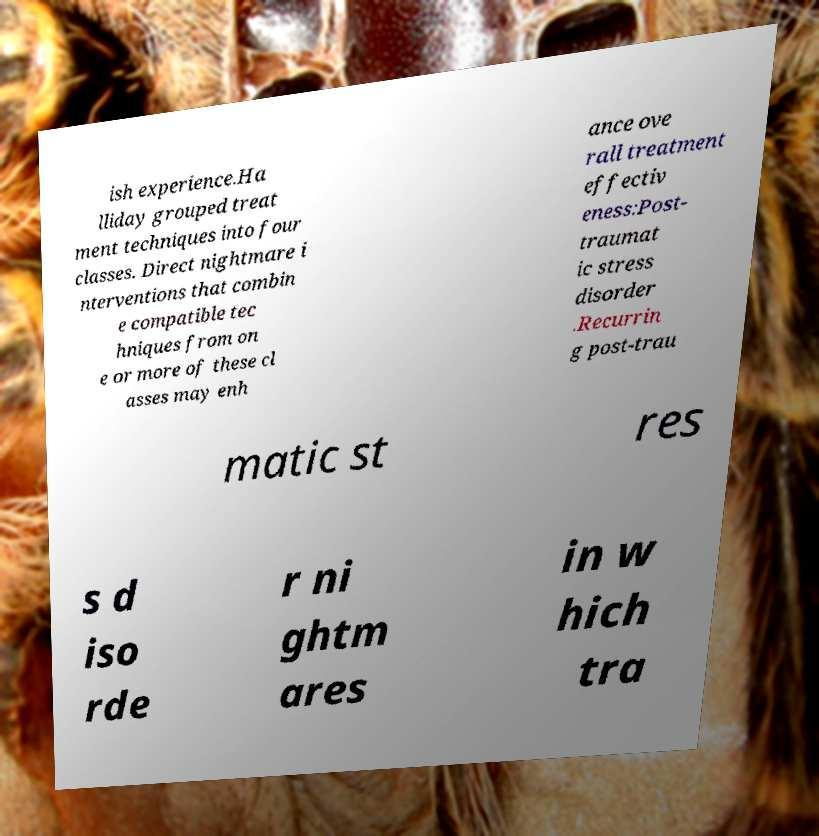Could you assist in decoding the text presented in this image and type it out clearly? ish experience.Ha lliday grouped treat ment techniques into four classes. Direct nightmare i nterventions that combin e compatible tec hniques from on e or more of these cl asses may enh ance ove rall treatment effectiv eness:Post- traumat ic stress disorder .Recurrin g post-trau matic st res s d iso rde r ni ghtm ares in w hich tra 